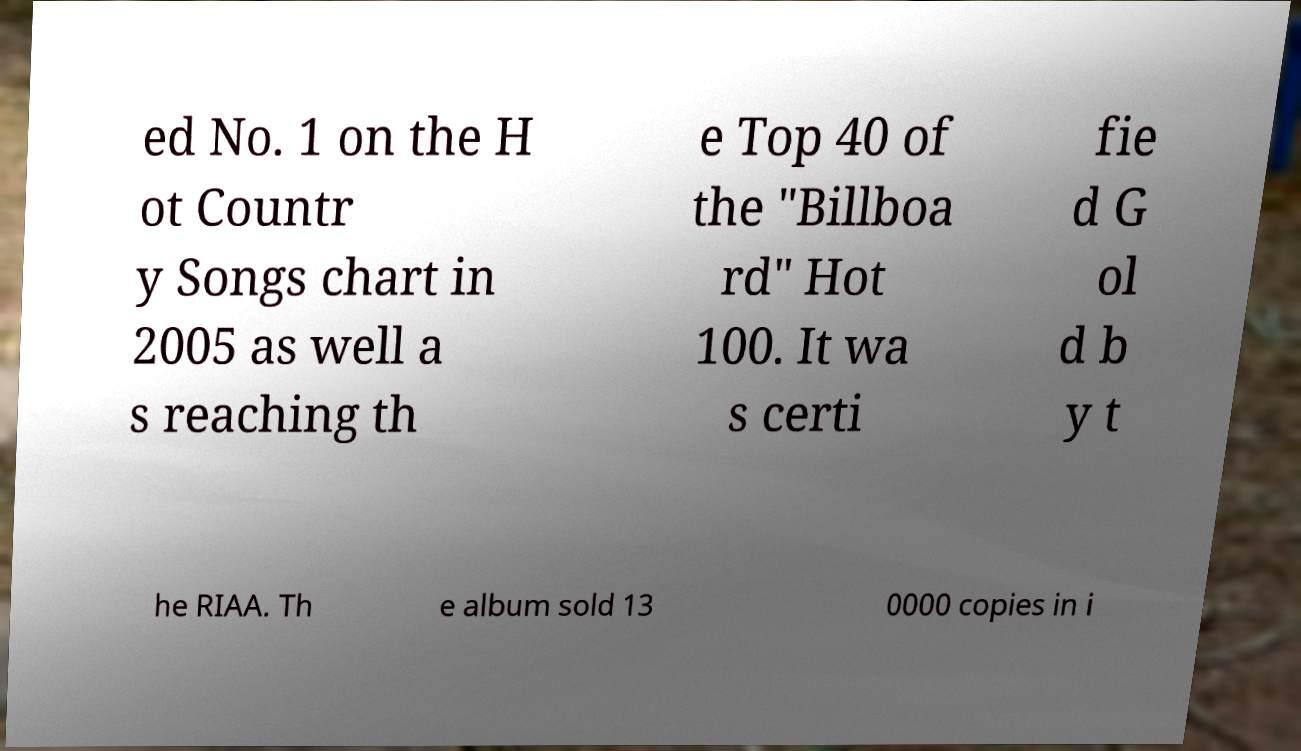Could you assist in decoding the text presented in this image and type it out clearly? ed No. 1 on the H ot Countr y Songs chart in 2005 as well a s reaching th e Top 40 of the "Billboa rd" Hot 100. It wa s certi fie d G ol d b y t he RIAA. Th e album sold 13 0000 copies in i 